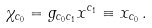<formula> <loc_0><loc_0><loc_500><loc_500>\chi _ { c _ { 0 } } = g _ { c _ { 0 } c _ { 1 } } x ^ { c _ { 1 } } \equiv x _ { c _ { 0 } } \, .</formula> 